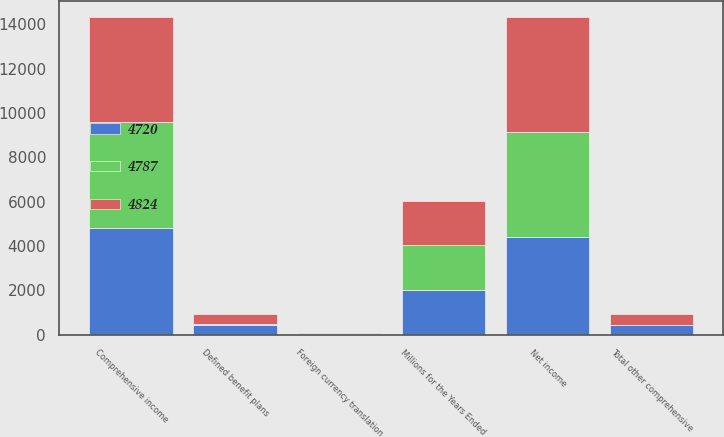<chart> <loc_0><loc_0><loc_500><loc_500><stacked_bar_chart><ecel><fcel>Millions for the Years Ended<fcel>Net income<fcel>Defined benefit plans<fcel>Foreign currency translation<fcel>Total other comprehensive<fcel>Comprehensive income<nl><fcel>4787<fcel>2015<fcel>4772<fcel>58<fcel>43<fcel>15<fcel>4787<nl><fcel>4824<fcel>2014<fcel>5180<fcel>448<fcel>12<fcel>460<fcel>4720<nl><fcel>4720<fcel>2013<fcel>4388<fcel>436<fcel>1<fcel>436<fcel>4824<nl></chart> 